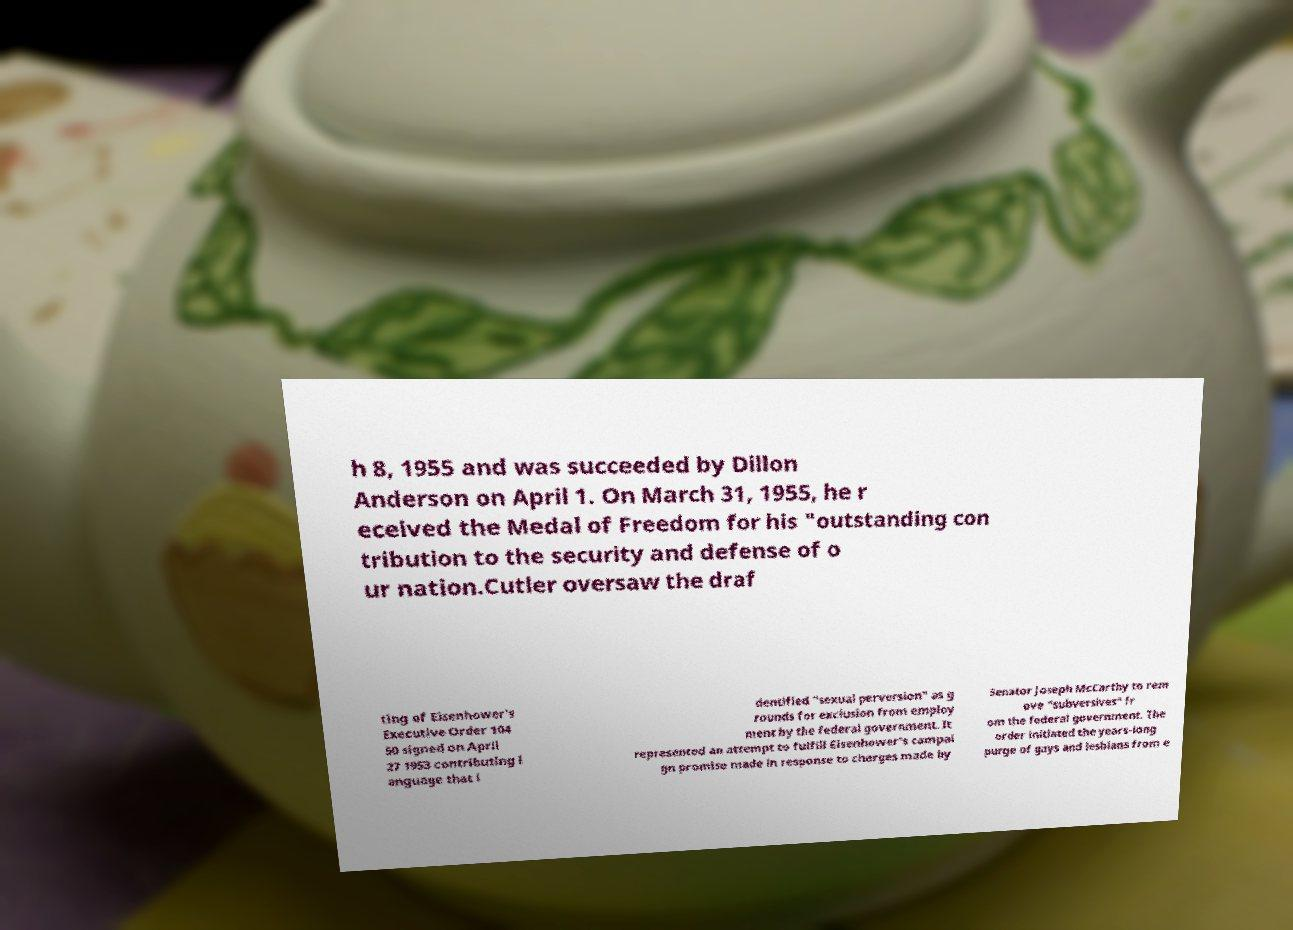Please read and relay the text visible in this image. What does it say? h 8, 1955 and was succeeded by Dillon Anderson on April 1. On March 31, 1955, he r eceived the Medal of Freedom for his "outstanding con tribution to the security and defense of o ur nation.Cutler oversaw the draf ting of Eisenhower's Executive Order 104 50 signed on April 27 1953 contributing l anguage that i dentified "sexual perversion" as g rounds for exclusion from employ ment by the federal government. It represented an attempt to fulfill Eisenhower's campai gn promise made in response to charges made by Senator Joseph McCarthy to rem ove "subversives" fr om the federal government. The order initiated the years-long purge of gays and lesbians from e 